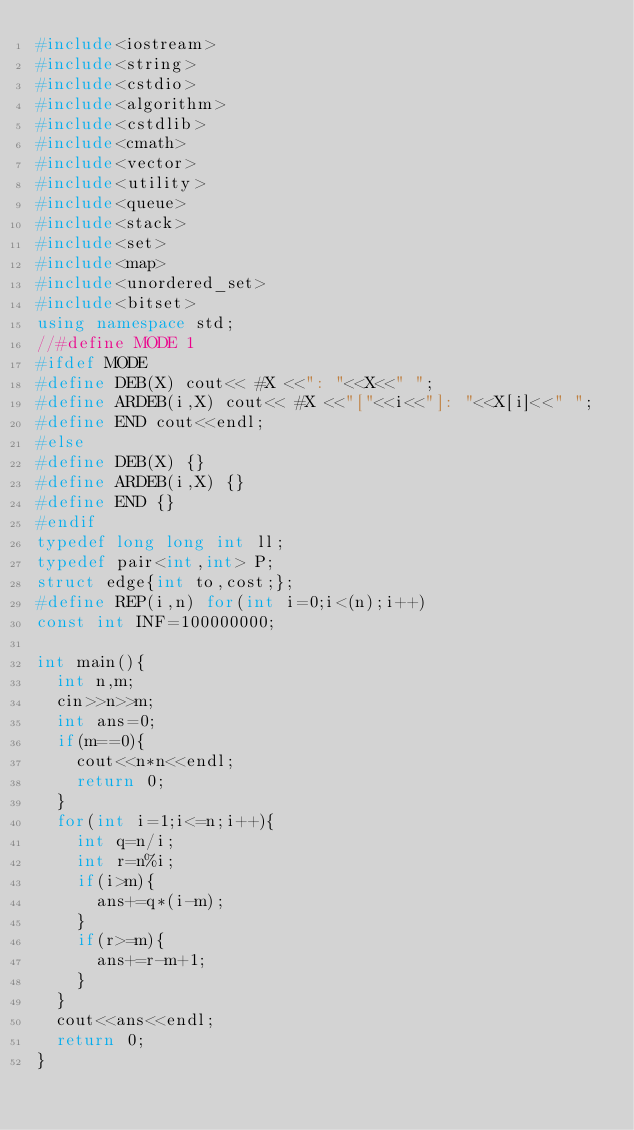<code> <loc_0><loc_0><loc_500><loc_500><_C++_>#include<iostream>
#include<string>
#include<cstdio>
#include<algorithm>
#include<cstdlib>
#include<cmath>
#include<vector>
#include<utility>
#include<queue>
#include<stack>
#include<set>
#include<map>
#include<unordered_set>
#include<bitset>
using namespace std;
//#define MODE 1
#ifdef MODE
#define DEB(X) cout<< #X <<": "<<X<<" ";
#define ARDEB(i,X) cout<< #X <<"["<<i<<"]: "<<X[i]<<" ";
#define END cout<<endl;
#else
#define DEB(X) {}
#define ARDEB(i,X) {}
#define END {}
#endif
typedef long long int ll;
typedef pair<int,int> P;
struct edge{int to,cost;};
#define REP(i,n) for(int i=0;i<(n);i++)
const int INF=100000000;

int main(){
	int n,m;
	cin>>n>>m;
	int ans=0;
	if(m==0){
		cout<<n*n<<endl;
		return 0;
	}
	for(int i=1;i<=n;i++){
		int q=n/i;
		int r=n%i;
		if(i>m){
			ans+=q*(i-m);
		}
		if(r>=m){
			ans+=r-m+1;
		}
	}
	cout<<ans<<endl;
	return 0;
}</code> 